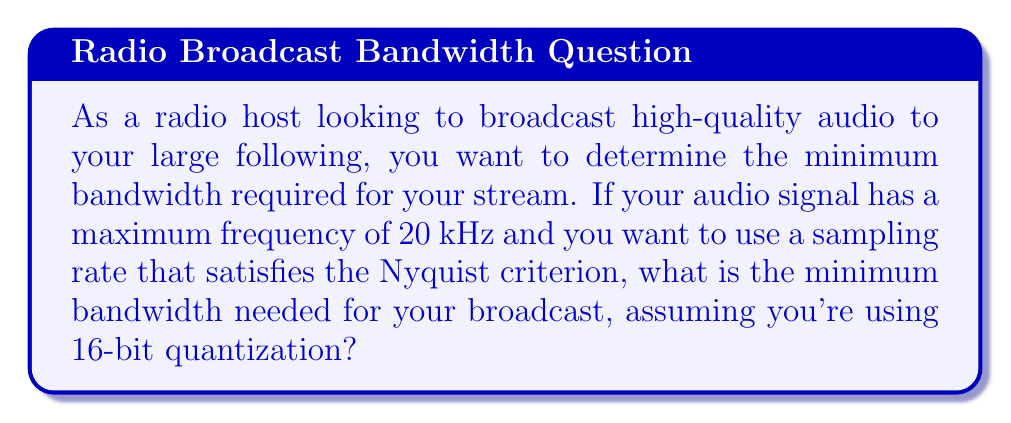Solve this math problem. To solve this problem, we need to follow these steps:

1. Determine the minimum sampling rate using the Nyquist criterion:
   The Nyquist criterion states that the sampling rate must be at least twice the highest frequency in the signal.
   
   $$f_s \geq 2f_{max}$$
   
   Where $f_s$ is the sampling rate and $f_{max}$ is the maximum frequency.
   
   $$f_s \geq 2 \cdot 20\text{ kHz} = 40\text{ kHz}$$

2. Calculate the number of bits per second:
   With 16-bit quantization, each sample requires 16 bits.
   
   $$\text{Bits per second} = f_s \cdot 16$$
   $$\text{Bits per second} = 40000 \cdot 16 = 640000\text{ bps}$$

3. Convert bits per second to bandwidth in Hz:
   In digital communication, 1 Hz of bandwidth typically corresponds to 2 bits per second (assuming ideal conditions and binary encoding).
   
   $$\text{Bandwidth} = \frac{\text{Bits per second}}{2}$$
   $$\text{Bandwidth} = \frac{640000}{2} = 320000\text{ Hz} = 320\text{ kHz}$$

Therefore, the minimum bandwidth required for broadcasting the high-quality audio stream is 320 kHz.
Answer: 320 kHz 